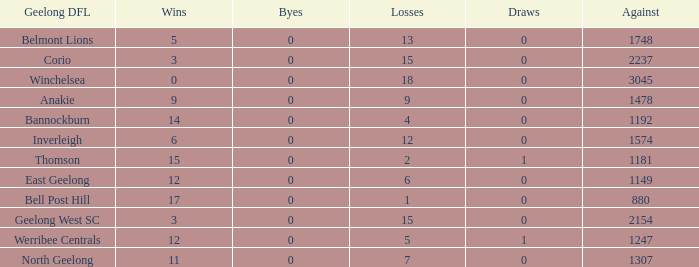What is the complete sum of losses when byes were above 0? 0.0. 